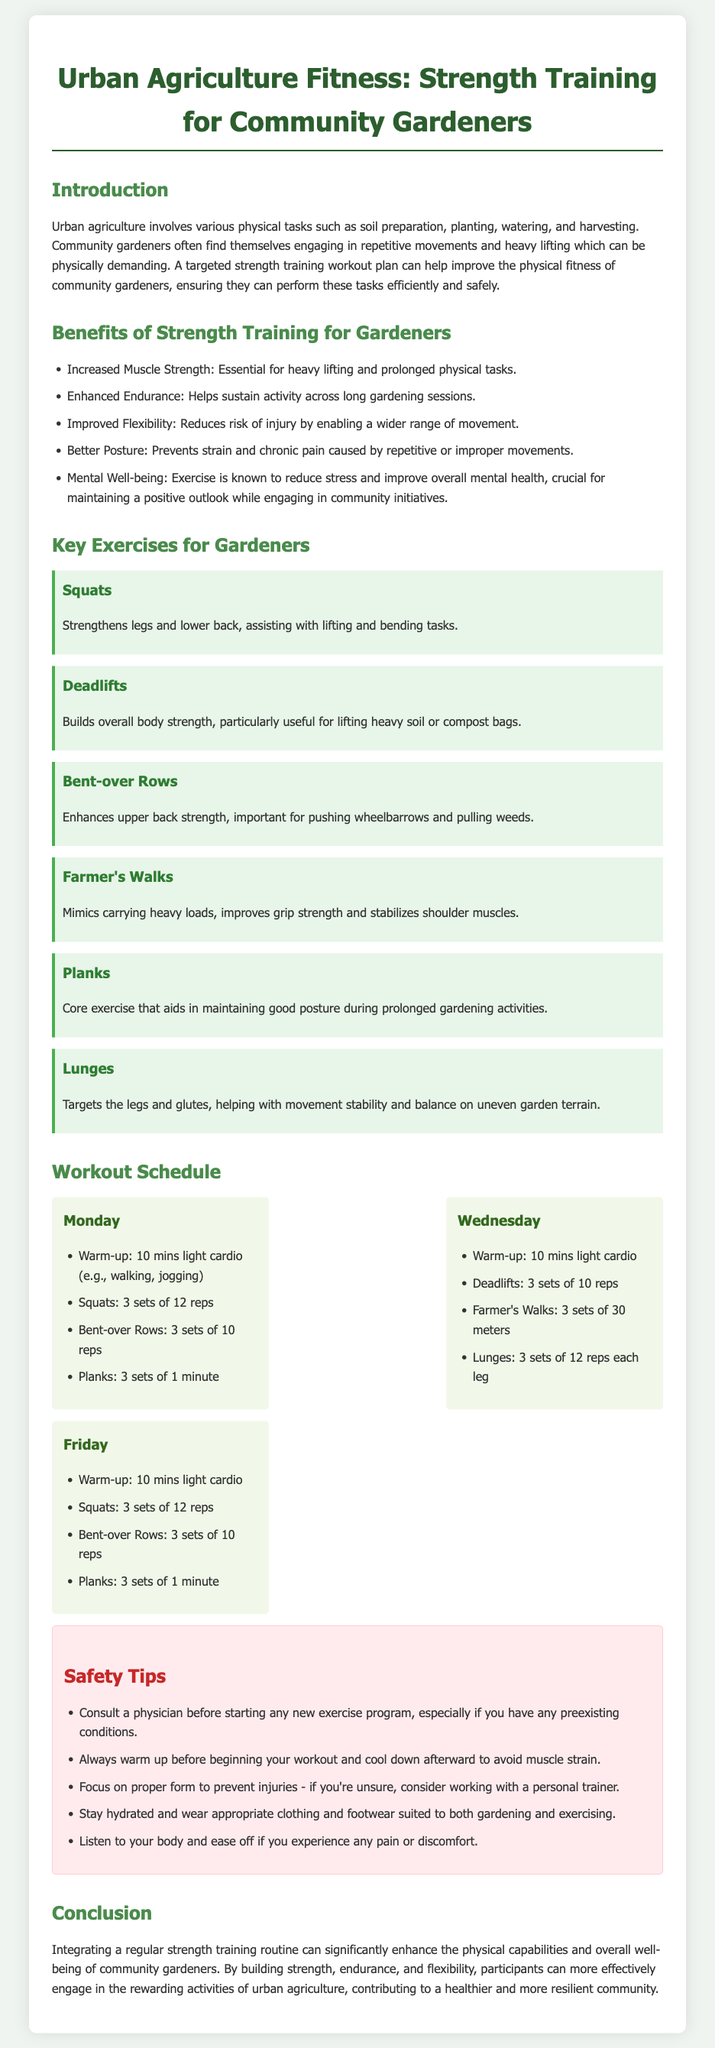What is the title of the document? The title of the document is clearly stated at the top of the page.
Answer: Urban Agriculture Fitness: Strength Training for Community Gardeners How many key exercises are listed for gardeners? The document lists several exercises aimed at strengthening different muscle groups beneficial for gardeners.
Answer: Six What is one benefit of strength training mentioned? The document outlines various benefits of strength training that cater specifically to community gardeners.
Answer: Increased Muscle Strength On which days are workouts scheduled? The document provides a specific workout schedule indicating the days of the week when exercises are to be completed.
Answer: Monday, Wednesday, Friday What is recommended as a warm-up activity? The document suggests a preliminary activity to prepare the body for exercise.
Answer: Light cardio How many sets of Squats are recommended on Monday? The document specifies the number of sets for Squats in the workout routine on Monday.
Answer: 3 sets What should one do before starting a new exercise program? The document gives a safety tip regarding medical advice prior to beginning a workout.
Answer: Consult a physician Which exercise aids in maintaining good posture? The document mentions various exercises and their specific benefits, including one that focuses on posture.
Answer: Planks 